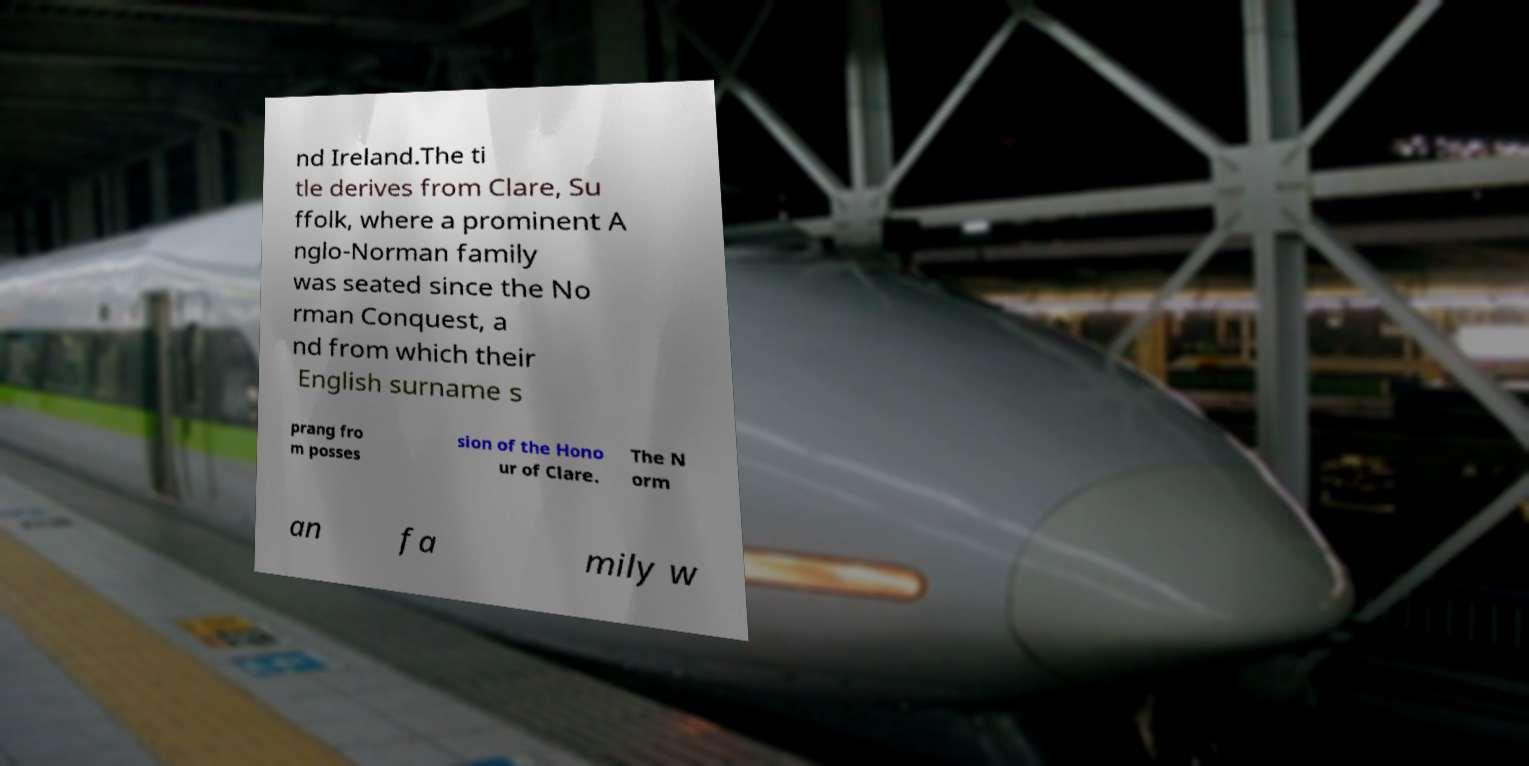Can you accurately transcribe the text from the provided image for me? nd Ireland.The ti tle derives from Clare, Su ffolk, where a prominent A nglo-Norman family was seated since the No rman Conquest, a nd from which their English surname s prang fro m posses sion of the Hono ur of Clare. The N orm an fa mily w 